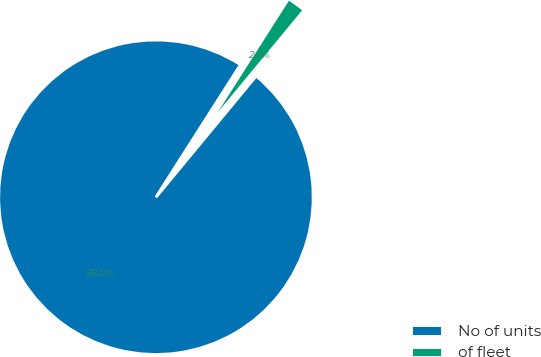Convert chart. <chart><loc_0><loc_0><loc_500><loc_500><pie_chart><fcel>No of units<fcel>of fleet<nl><fcel>98.04%<fcel>1.96%<nl></chart> 